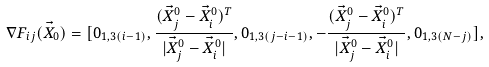Convert formula to latex. <formula><loc_0><loc_0><loc_500><loc_500>\nabla F _ { i j } ( \vec { X } _ { 0 } ) = [ 0 _ { 1 , 3 ( i - 1 ) } , \frac { ( \vec { X } ^ { 0 } _ { j } - \vec { X } ^ { 0 } _ { i } ) ^ { T } } { | \vec { X } ^ { 0 } _ { j } - \vec { X } ^ { 0 } _ { i } | } , 0 _ { 1 , 3 ( j - i - 1 ) } , - \frac { ( \vec { X } ^ { 0 } _ { j } - \vec { X } ^ { 0 } _ { i } ) ^ { T } } { | \vec { X } ^ { 0 } _ { j } - \vec { X } ^ { 0 } _ { i } | } , 0 _ { 1 , 3 ( N - j ) } ] ,</formula> 